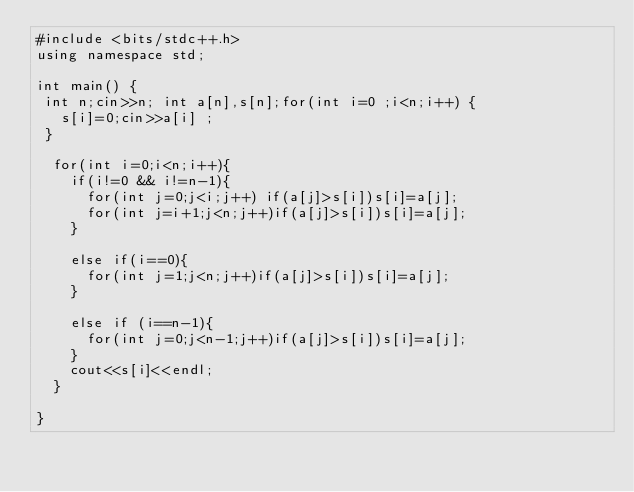Convert code to text. <code><loc_0><loc_0><loc_500><loc_500><_C++_>#include <bits/stdc++.h>
using namespace std;

int main() {
 int n;cin>>n; int a[n],s[n];for(int i=0 ;i<n;i++) {
   s[i]=0;cin>>a[i] ;
 }
  
  for(int i=0;i<n;i++){
    if(i!=0 && i!=n-1){
      for(int j=0;j<i;j++) if(a[j]>s[i])s[i]=a[j];
      for(int j=i+1;j<n;j++)if(a[j]>s[i])s[i]=a[j];
    }
    
    else if(i==0){
      for(int j=1;j<n;j++)if(a[j]>s[i])s[i]=a[j];
    }
    
    else if (i==n-1){
      for(int j=0;j<n-1;j++)if(a[j]>s[i])s[i]=a[j];
    }
    cout<<s[i]<<endl;
  }
  
}</code> 